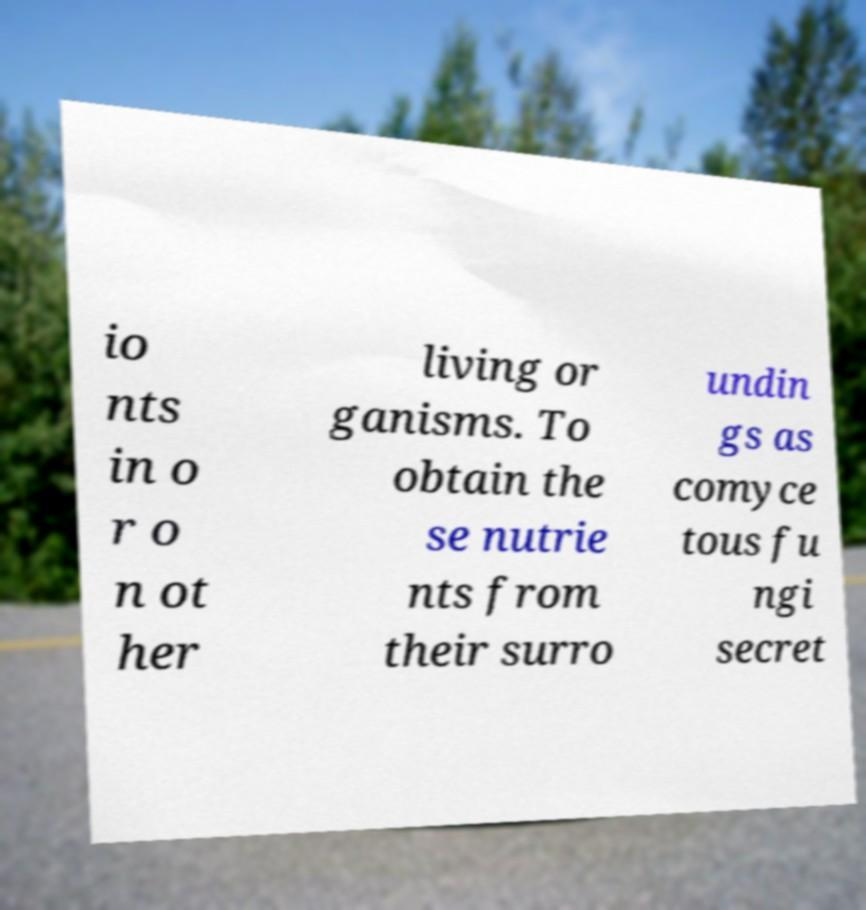For documentation purposes, I need the text within this image transcribed. Could you provide that? io nts in o r o n ot her living or ganisms. To obtain the se nutrie nts from their surro undin gs as comyce tous fu ngi secret 